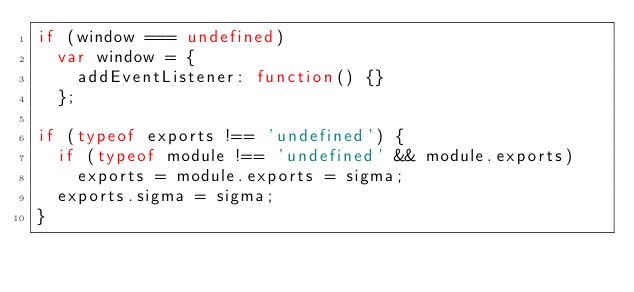Convert code to text. <code><loc_0><loc_0><loc_500><loc_500><_JavaScript_>if (window === undefined)
  var window = {
    addEventListener: function() {}
  };

if (typeof exports !== 'undefined') {
  if (typeof module !== 'undefined' && module.exports)
    exports = module.exports = sigma;
  exports.sigma = sigma;
}
</code> 